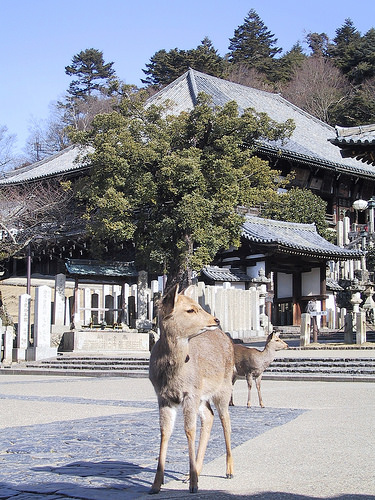<image>
Is the deer in front of the deer? Yes. The deer is positioned in front of the deer, appearing closer to the camera viewpoint. 